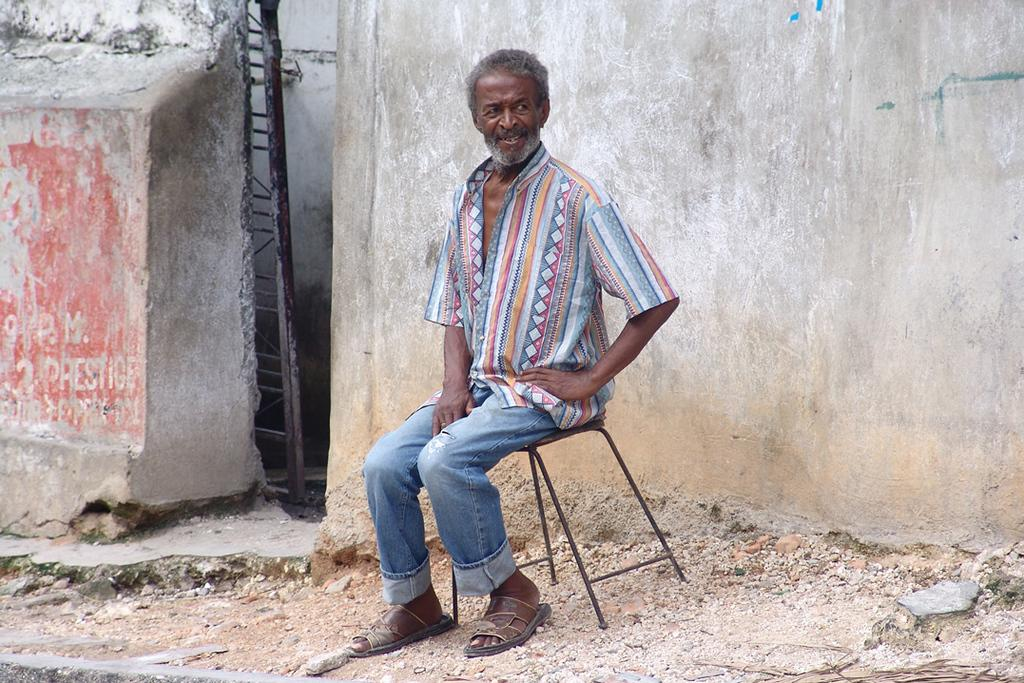What is the person in the image doing? The person is sitting on a stool in the image. What can be seen in the background of the image? There is a gate and a wall in the background of the image. What type of heart is visible in the image? There is no heart present in the image. What part of the brain can be seen in the image? There is no brain present in the image. 